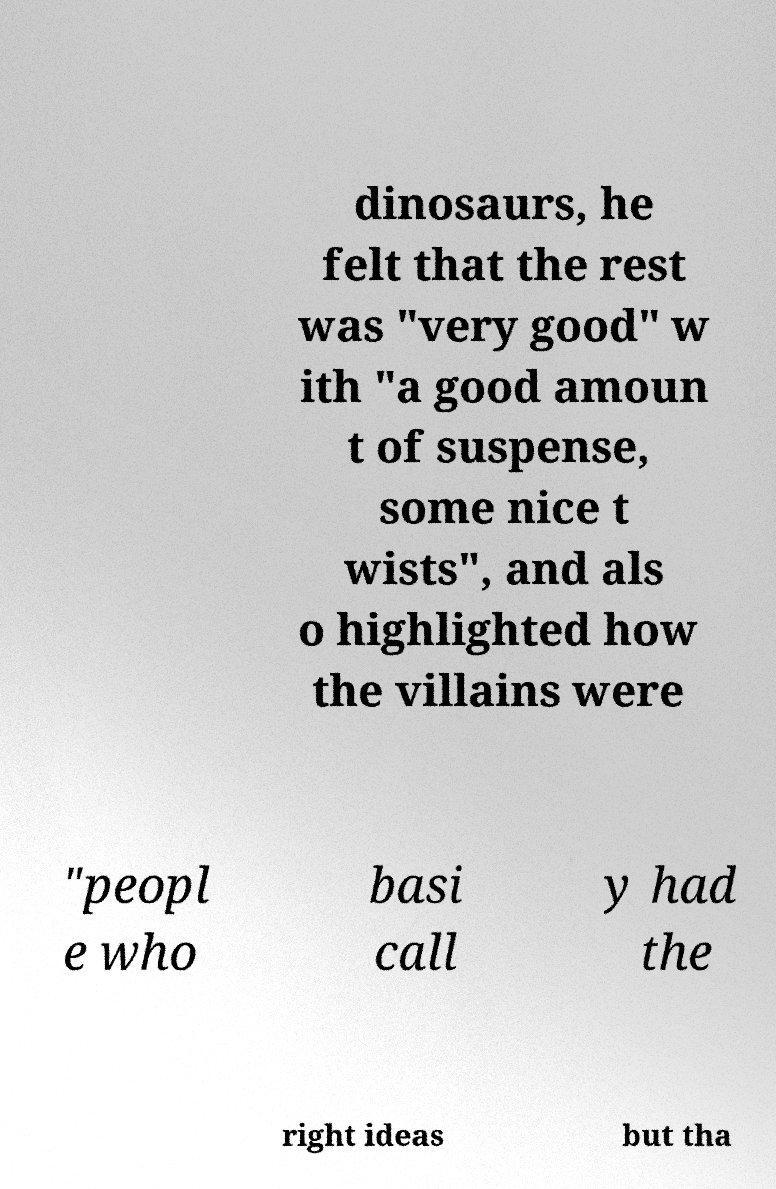For documentation purposes, I need the text within this image transcribed. Could you provide that? dinosaurs, he felt that the rest was "very good" w ith "a good amoun t of suspense, some nice t wists", and als o highlighted how the villains were "peopl e who basi call y had the right ideas but tha 